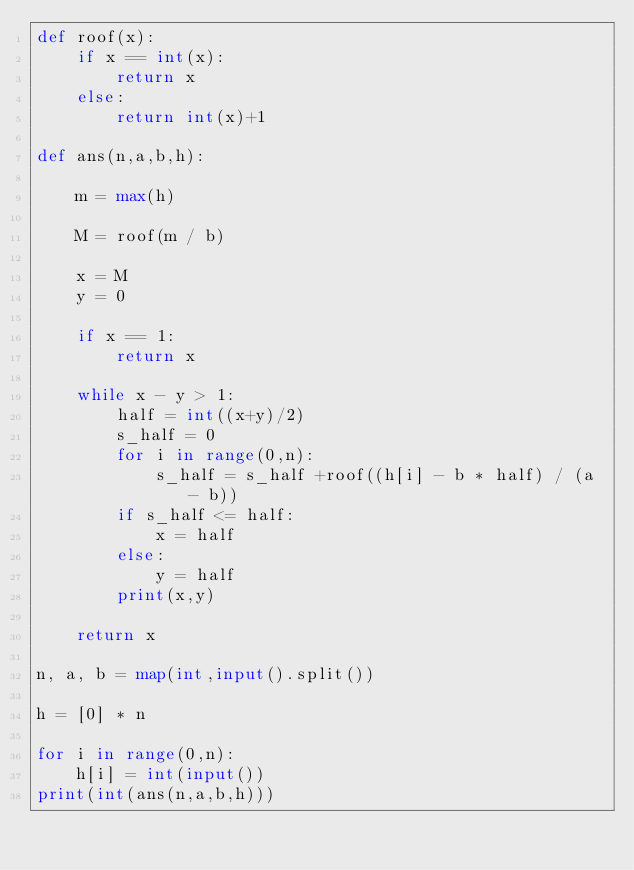Convert code to text. <code><loc_0><loc_0><loc_500><loc_500><_Python_>def roof(x):
    if x == int(x):
        return x
    else:
        return int(x)+1

def ans(n,a,b,h):
    
    m = max(h)

    M = roof(m / b)
    
    x = M
    y = 0
    
    if x == 1:
        return x
    
    while x - y > 1:
        half = int((x+y)/2)
        s_half = 0
        for i in range(0,n):
            s_half = s_half +roof((h[i] - b * half) / (a - b))
        if s_half <= half:
            x = half
        else:
            y = half
        print(x,y)
    
    return x
    
n, a, b = map(int,input().split())

h = [0] * n

for i in range(0,n):
    h[i] = int(input())
print(int(ans(n,a,b,h)))</code> 